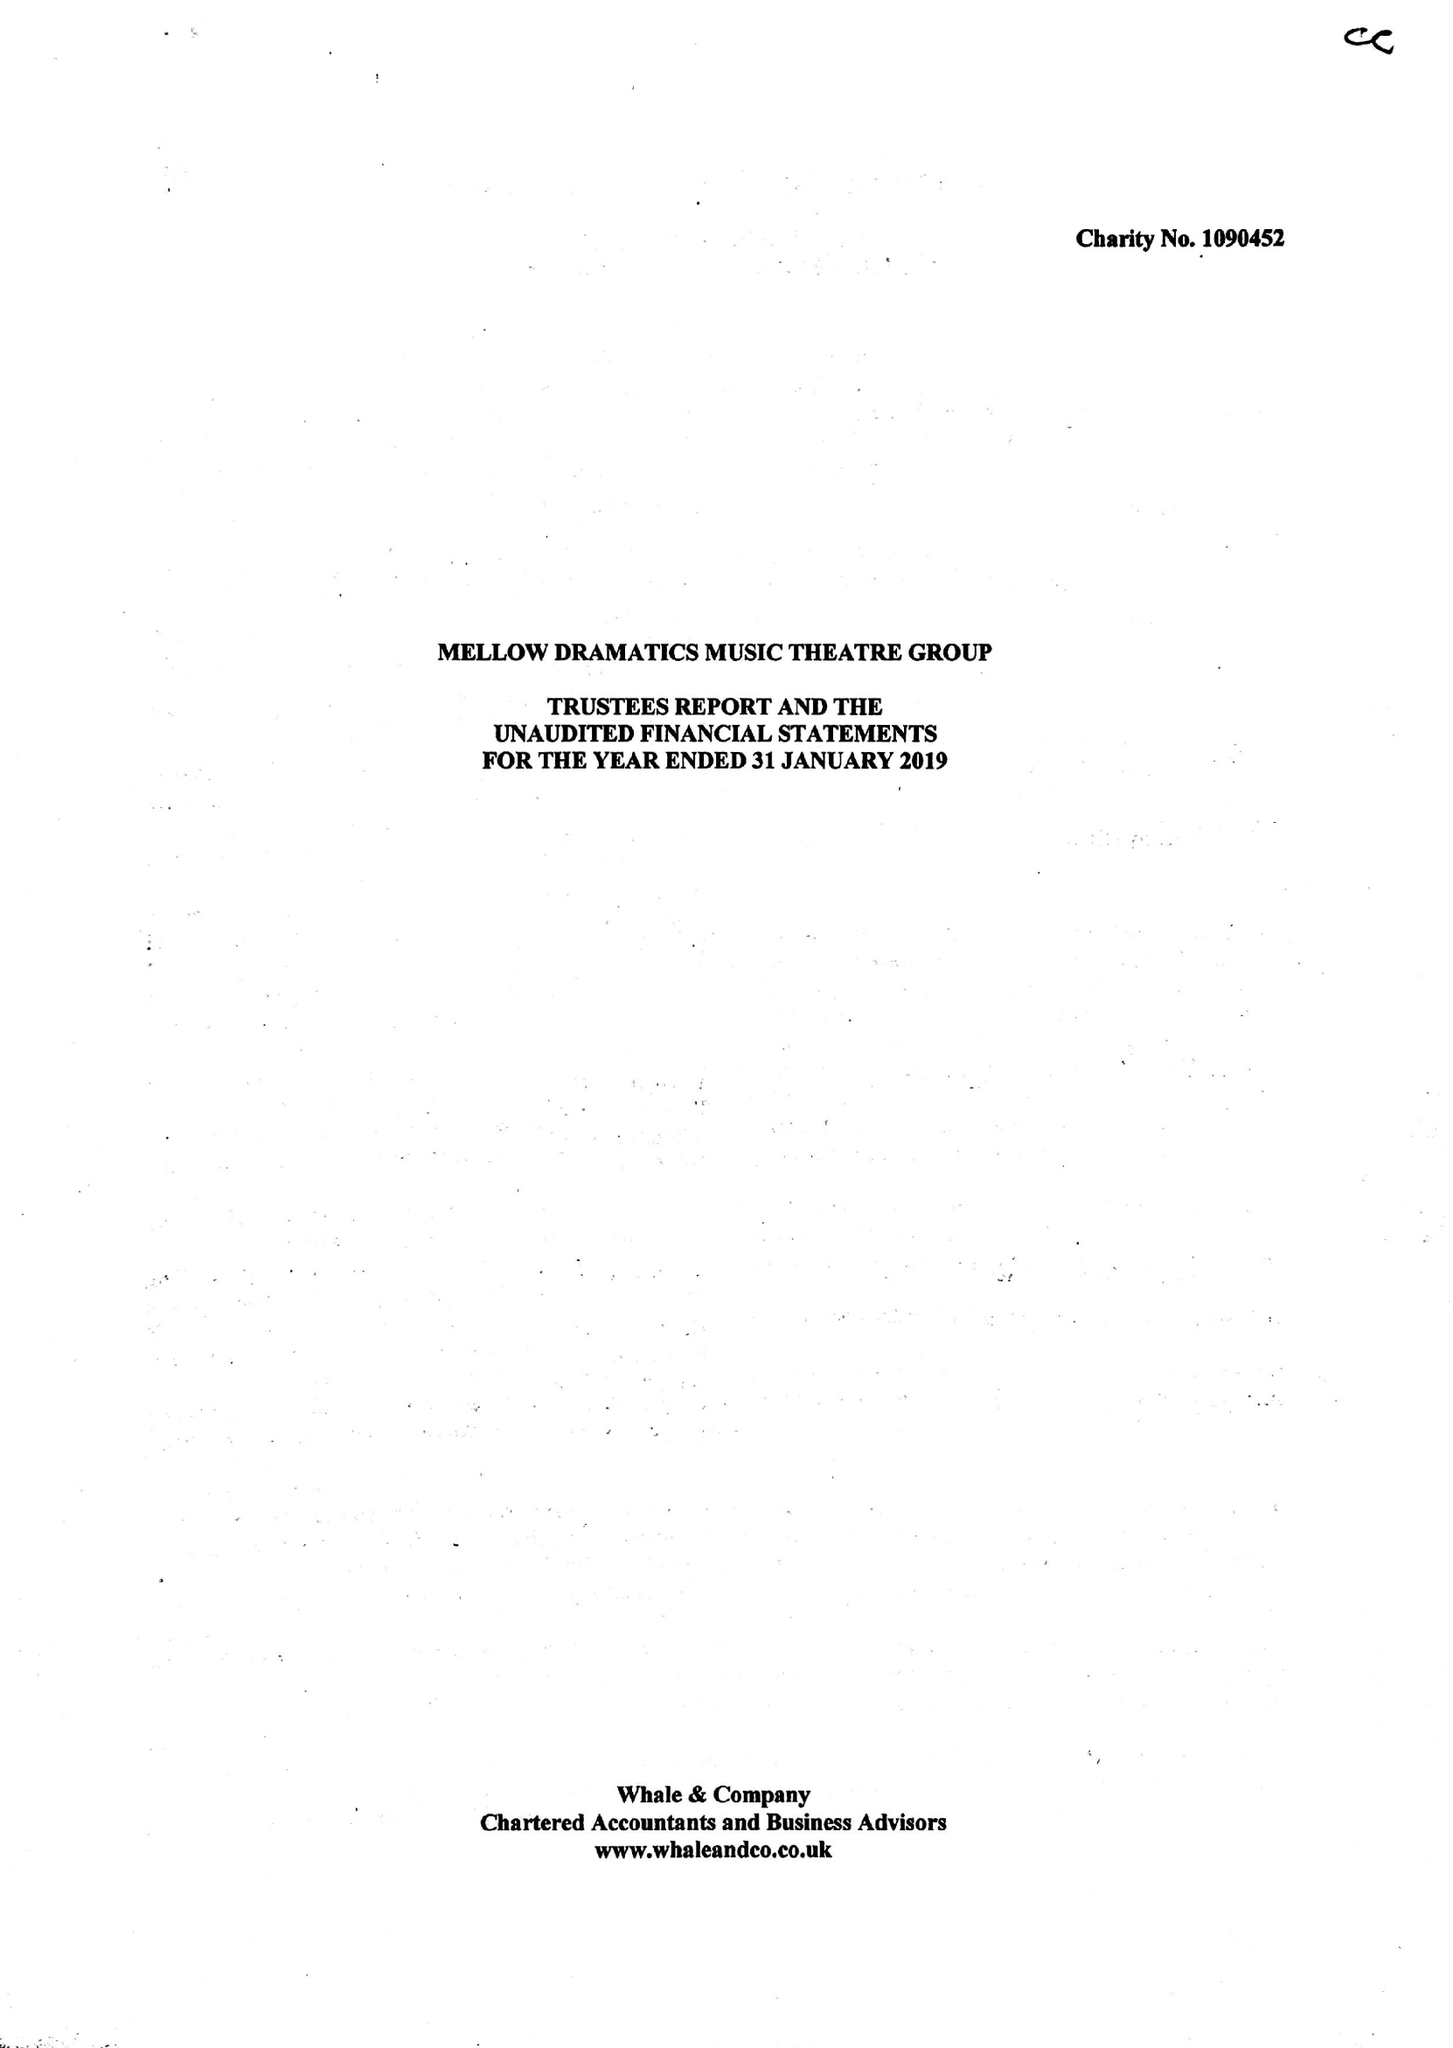What is the value for the charity_number?
Answer the question using a single word or phrase. 1090452 